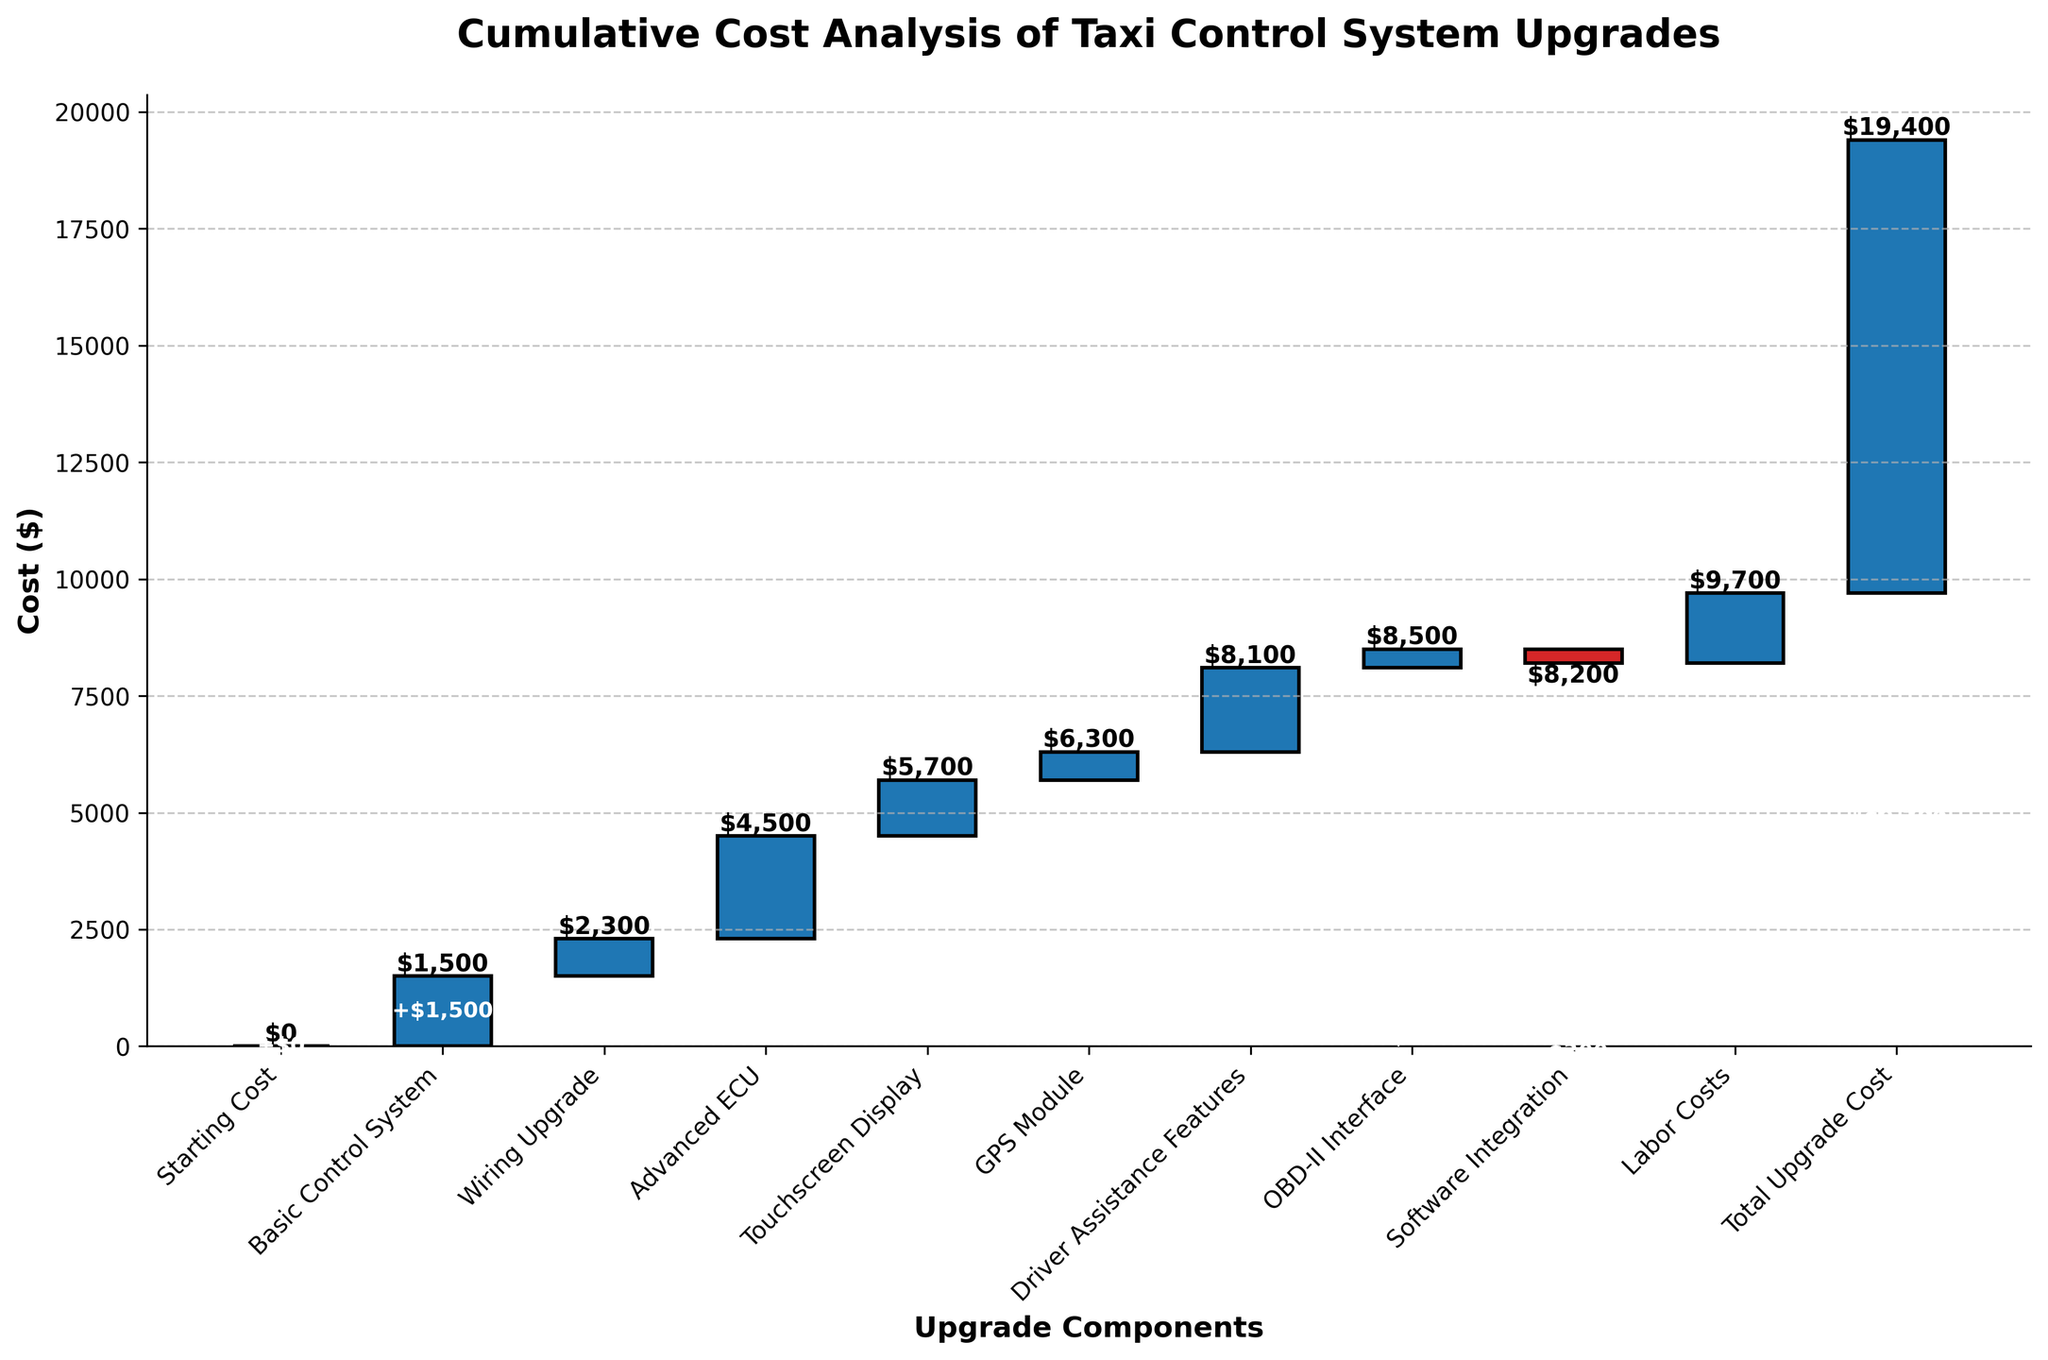What is the title of the waterfall chart? The title of the chart is written prominently at the top and it reads "Cumulative Cost Analysis of Taxi Control System Upgrades".
Answer: Cumulative Cost Analysis of Taxi Control System Upgrades How many upgrade components are listed in the chart? By counting the number of bars (each representing an upgrade component) in the chart, we find there are 10 components listed.
Answer: 10 What is the total cost of all upgrades combined? The final bar in the waterfall chart represents the total cumulative cost of all the upgrades, which reads $9700.
Answer: $9700 Which component incurs the highest cost? By looking at the tallest individual bar, the "Advanced ECU" has the highest value at $2200.
Answer: Advanced ECU What is the cost difference between the Basic Control System and the Driver Assistance Features? The bar for "Basic Control System" is $1500 and "Driver Assistance Features" is $1800. Subtracting these, $1800 - $1500 = $300.
Answer: $300 What is the overall effect of the Software Integration on the total cost? The bar for "Software Integration" has a negative value, showing a reduction to the total, which is -$300.
Answer: -$300 Which components together exceed the cost of the Advanced ECU? Summing individual component costs greater than $2200 (Advanced ECU) together, we find: "Basic Control System" ($1500) + "Wiring Upgrade" ($800) = $2300. This exceeds $2200.
Answer: Basic Control System and Wiring Upgrade List the components that have a positive impact on the total cost. Positive impacts are visualized by the upward bars; they include "Basic Control System", "Wiring Upgrade", "Advanced ECU", "Touchscreen Display", "GPS Module", "Driver Assistance Features", "OBD-II Interface", and "Labor Costs".
Answer: Basic Control System, Wiring Upgrade, Advanced ECU, Touchscreen Display, GPS Module, Driver Assistance Features, OBD-II Interface, Labor Costs By how much does the OBD-II Interface alone increase the total cost? The OBD-II Interface bar is labelled, showing an individual increase of $400 to the total.
Answer: $400 After accounting for the Software Integration, what is the cumulative cost? Calculating up to the Software Integration step: Start with $0, add "Basic Control System" ($1500), "Wiring Upgrade" ($800), "Advanced ECU" ($2200), "Touchscreen Display" ($1200), "GPS Module" ($600), "Driver Assistance Features" ($1800), "OBD-II Interface" ($400), then subtract "Software Integration" ($-300) => $1,500 + $800 + $2,200 + $1,200 + $600 + $1,800 + $400 - $300 = $8,200.
Answer: $8200 